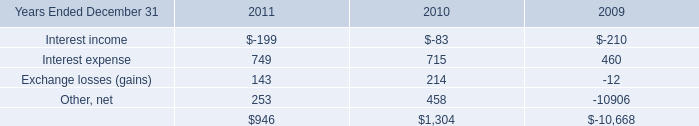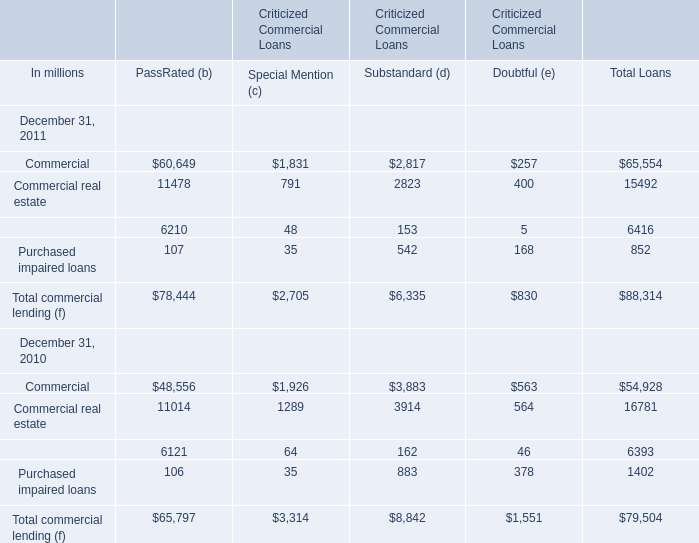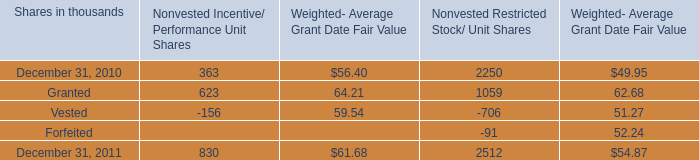What is the percentage of Commercial in relation to the total in 2011 for PassRated (b)? 
Computations: (60649 / 78444)
Answer: 0.77315. 